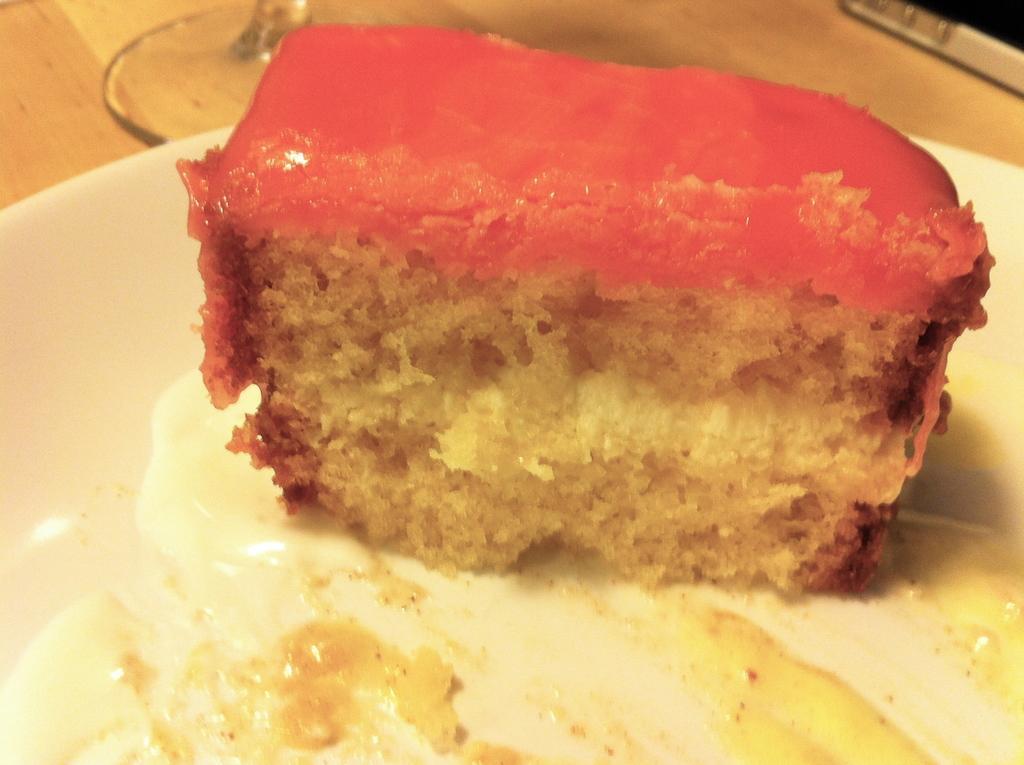Please provide a concise description of this image. In this image there is a slice of a pastry on the plate. Beside that there is a glass which was placed on the table. 